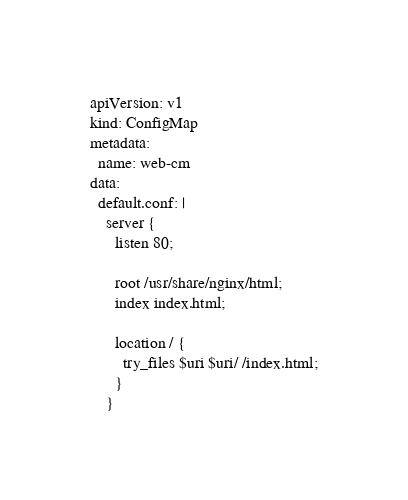Convert code to text. <code><loc_0><loc_0><loc_500><loc_500><_YAML_>apiVersion: v1
kind: ConfigMap
metadata:
  name: web-cm
data:
  default.conf: |
    server {
      listen 80;

      root /usr/share/nginx/html;
      index index.html;

      location / {
        try_files $uri $uri/ /index.html;
      }
    }
</code> 